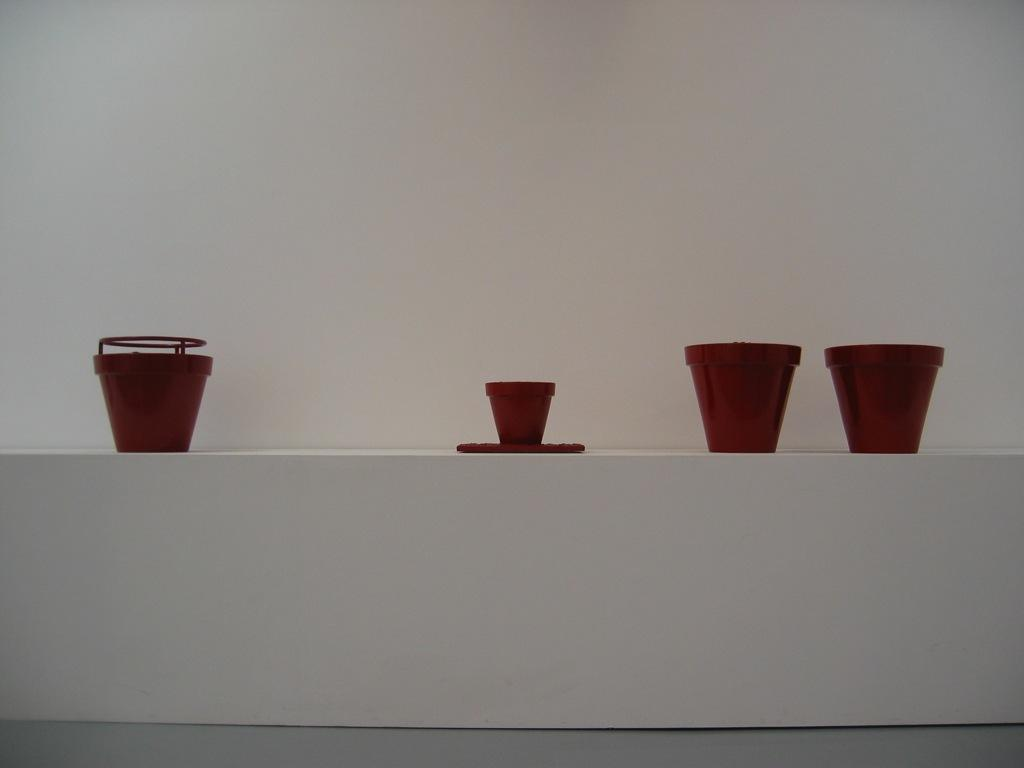What color are the plant pots in the image? The plant pots in the image are brown. How many different sizes of plant pots are there in the image? There are two different sizes of plant pots in the image. What can be seen in the background of the image? There is a wall in the background of the image. What type of blade is being used to drive the plant pots in the image? There is no blade or driving activity present in the image; it features plant pots of different sizes and a wall in the background. 